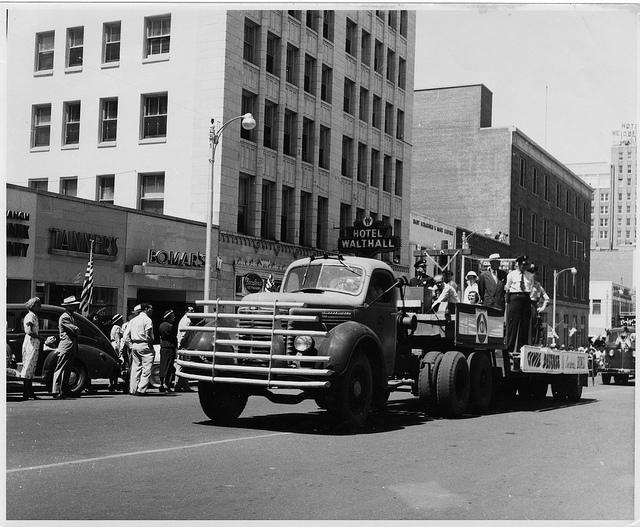How can you tell this photo was before this century?
Short answer required. Vehicles. Is there a parade happening?
Short answer required. Yes. Is this downtown?
Keep it brief. Yes. 